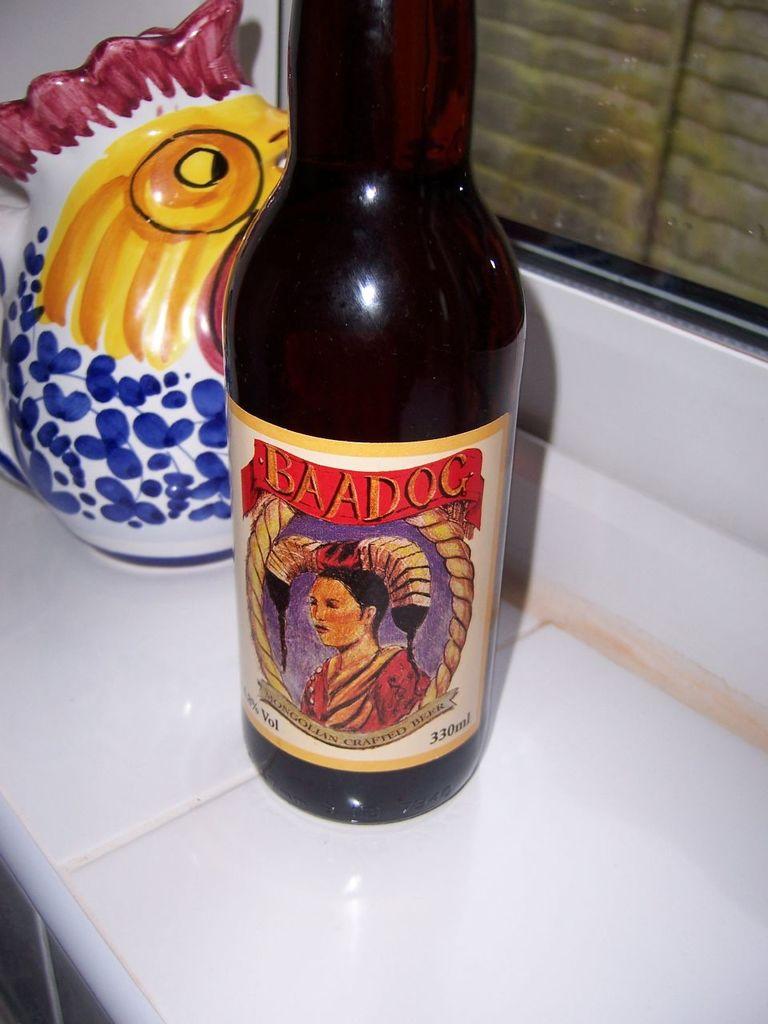What kind if beer is this?
Offer a very short reply. Baadog. 